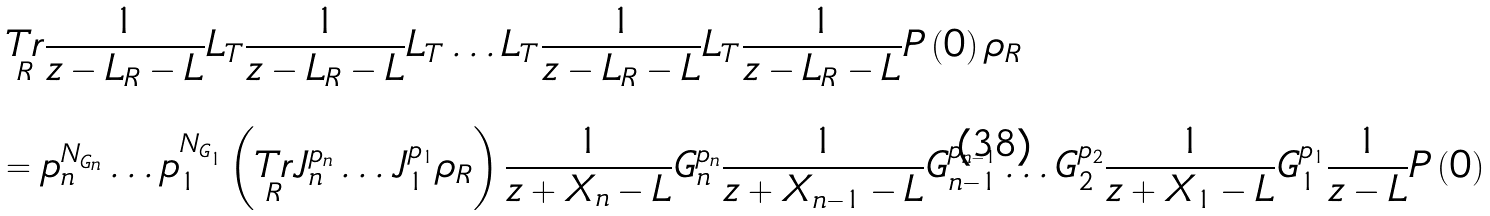<formula> <loc_0><loc_0><loc_500><loc_500>\text {$\begin{array}{lll}   \underset{\text {R}}{\text {Tr}} \frac{1}{z - L_{\text {R}} - L}   L_{\text {T}} \frac{1}{z - L_{\text {R}} - L} L_{\text {T}} \dots   L_{\text {T}} \frac{1}{z - L_{\text {R}} - L} L_{\text {T}}   \frac{1}{z - L_{\text {R}} - L} P \left( 0 \right)   \rho_{\text {R}} \\   \\   = p_{n}^{N_{G_{n}}} \dots p_{1}^{N_{G_{1}}}   \left( \underset{\text {R}}{\text {Tr}} J_{n}^{p_{n}} \dots J_{1}^{p_{1}} \rho_{\text {R}} \right)   \frac{1}{z + X_{n} - L} G^{p_{n}}_{n} \frac{1}{z + X_{n - 1} -   L} G^{p_{n - 1}}_{n - 1} \dots G^{p_{2}}_{2} \frac{1}{z + X_{1} -   L} G^{p_{1}}_{1} \frac{1}{z - L} P \left( 0 \right)   & &  \end{array}$}</formula> 